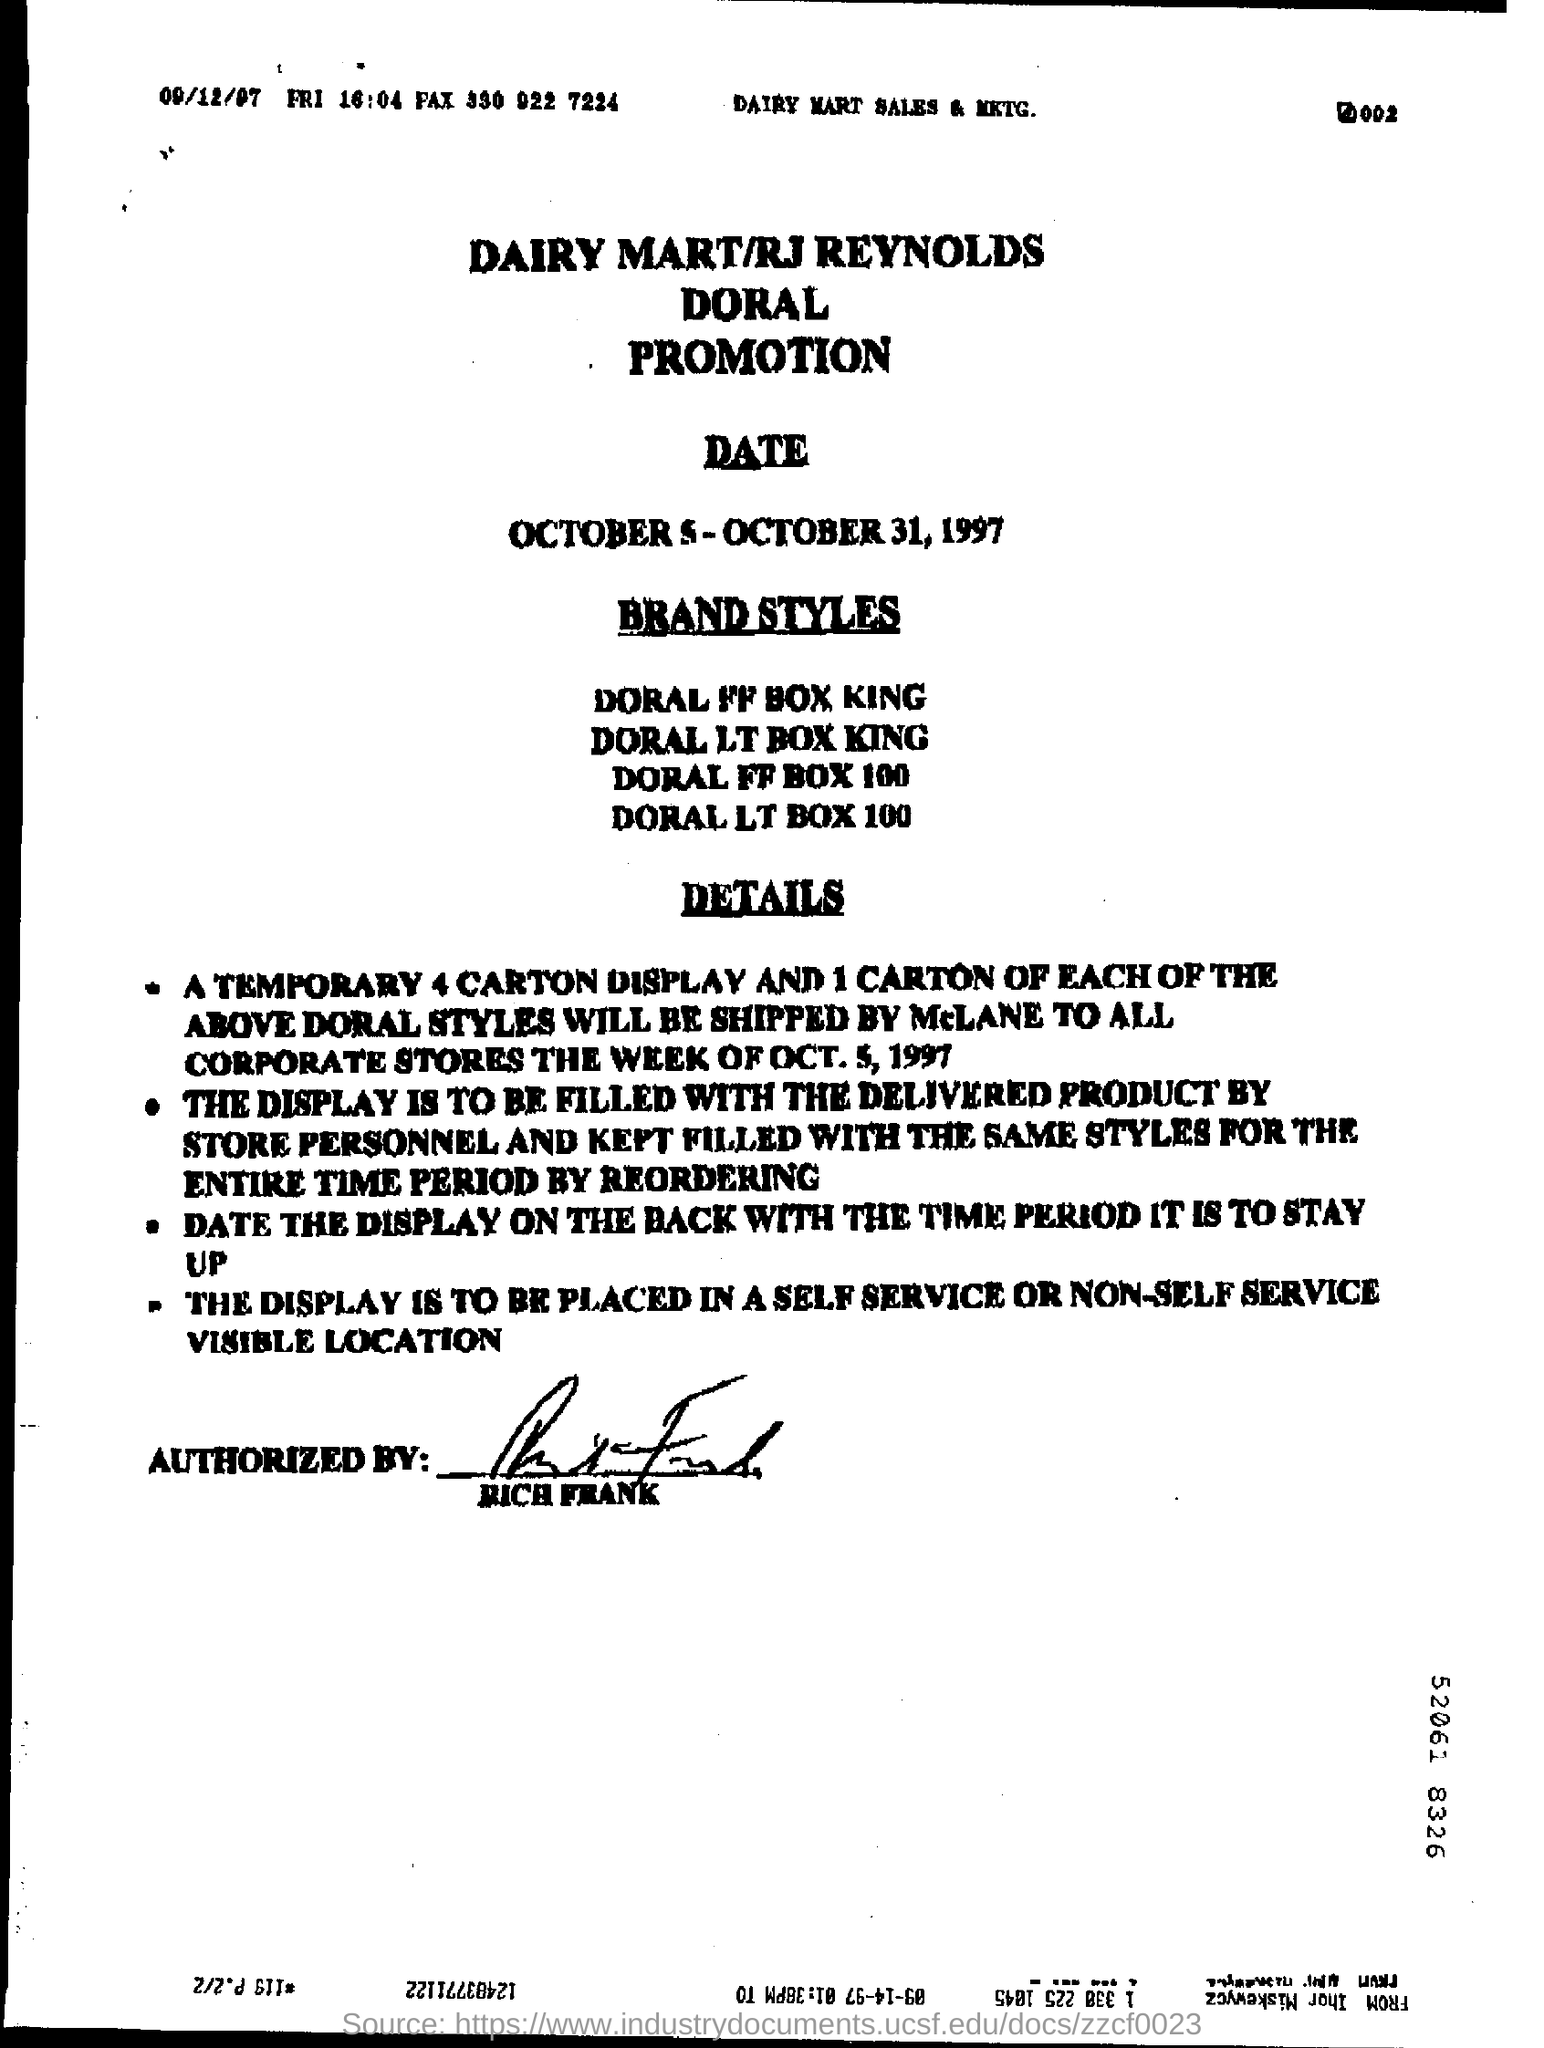Which brand's Promotion is this?
Offer a terse response. DAIRY MART/RJ REYNOLDS DORAL PROMOTION. At what Date, the promotion is scheduled?
Ensure brevity in your answer.  October 5 - october 31 , 1997. Who has signed the document?
Ensure brevity in your answer.  RICH FRANK. 